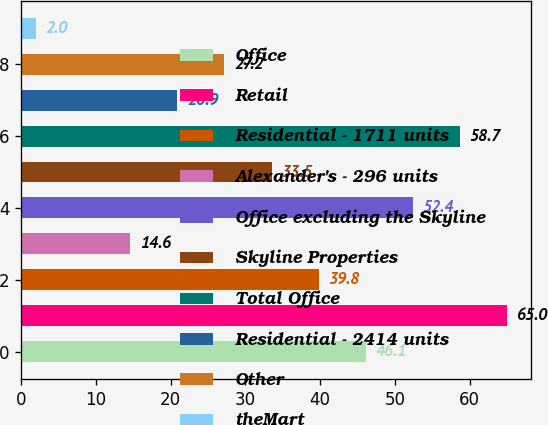Convert chart. <chart><loc_0><loc_0><loc_500><loc_500><bar_chart><fcel>Office<fcel>Retail<fcel>Residential - 1711 units<fcel>Alexander's - 296 units<fcel>Office excluding the Skyline<fcel>Skyline Properties<fcel>Total Office<fcel>Residential - 2414 units<fcel>Other<fcel>theMart<nl><fcel>46.1<fcel>65<fcel>39.8<fcel>14.6<fcel>52.4<fcel>33.5<fcel>58.7<fcel>20.9<fcel>27.2<fcel>2<nl></chart> 